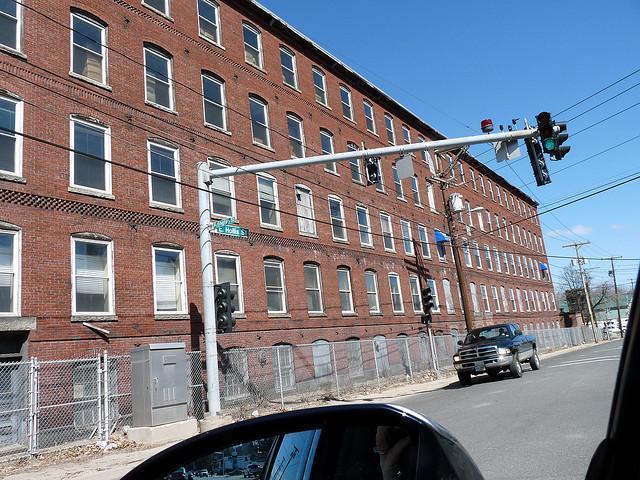How many windows are open?
Give a very brief answer. 0. How many cars are there?
Give a very brief answer. 2. 